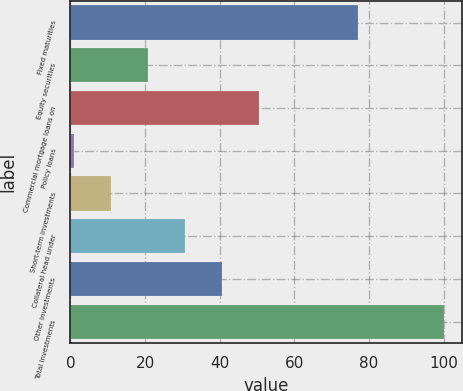Convert chart to OTSL. <chart><loc_0><loc_0><loc_500><loc_500><bar_chart><fcel>Fixed maturities<fcel>Equity securities<fcel>Commercial mortgage loans on<fcel>Policy loans<fcel>Short-term investments<fcel>Collateral head under<fcel>Other investments<fcel>Total investments<nl><fcel>77<fcel>20.8<fcel>50.5<fcel>1<fcel>10.9<fcel>30.7<fcel>40.6<fcel>100<nl></chart> 